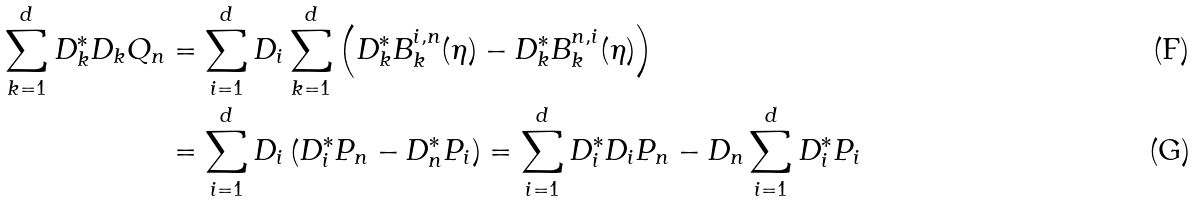<formula> <loc_0><loc_0><loc_500><loc_500>\sum _ { k = 1 } ^ { d } D ^ { * } _ { k } D _ { k } Q _ { n } & = \sum _ { i = 1 } ^ { d } D _ { i } \sum _ { k = 1 } ^ { d } \left ( D ^ { * } _ { k } B ^ { i , n } _ { k } ( \eta ) - D ^ { * } _ { k } B ^ { n , i } _ { k } ( \eta ) \right ) \\ & = \sum _ { i = 1 } ^ { d } D _ { i } \left ( D ^ { * } _ { i } P _ { n } - D ^ { * } _ { n } P _ { i } \right ) = \sum _ { i = 1 } ^ { d } D _ { i } ^ { * } D _ { i } P _ { n } - D _ { n } \sum _ { i = 1 } ^ { d } D ^ { * } _ { i } P _ { i }</formula> 